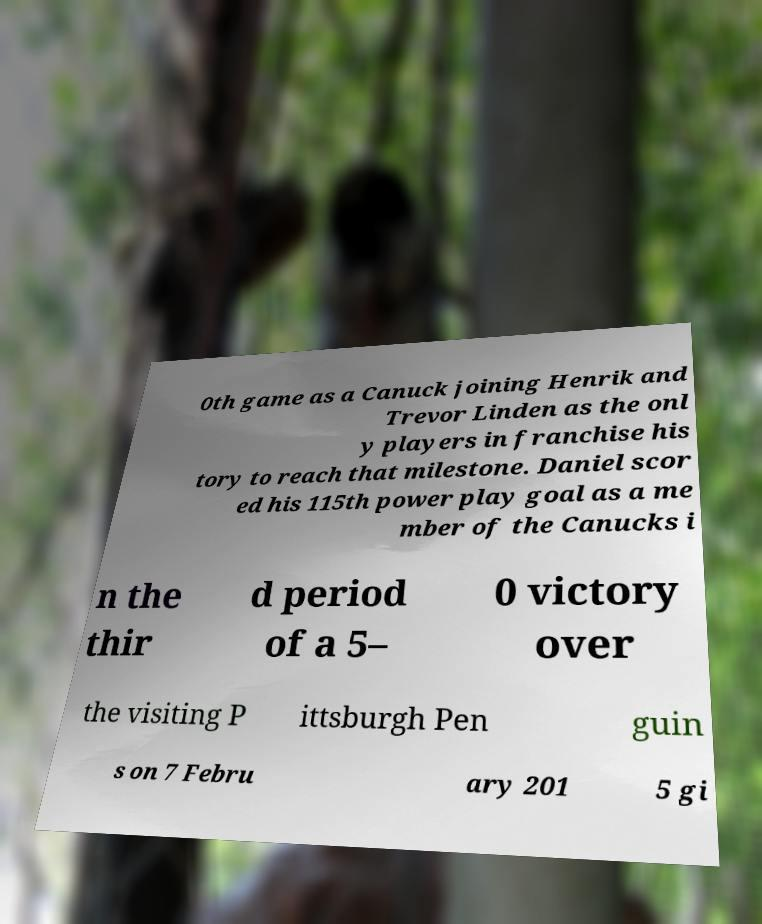For documentation purposes, I need the text within this image transcribed. Could you provide that? 0th game as a Canuck joining Henrik and Trevor Linden as the onl y players in franchise his tory to reach that milestone. Daniel scor ed his 115th power play goal as a me mber of the Canucks i n the thir d period of a 5– 0 victory over the visiting P ittsburgh Pen guin s on 7 Febru ary 201 5 gi 